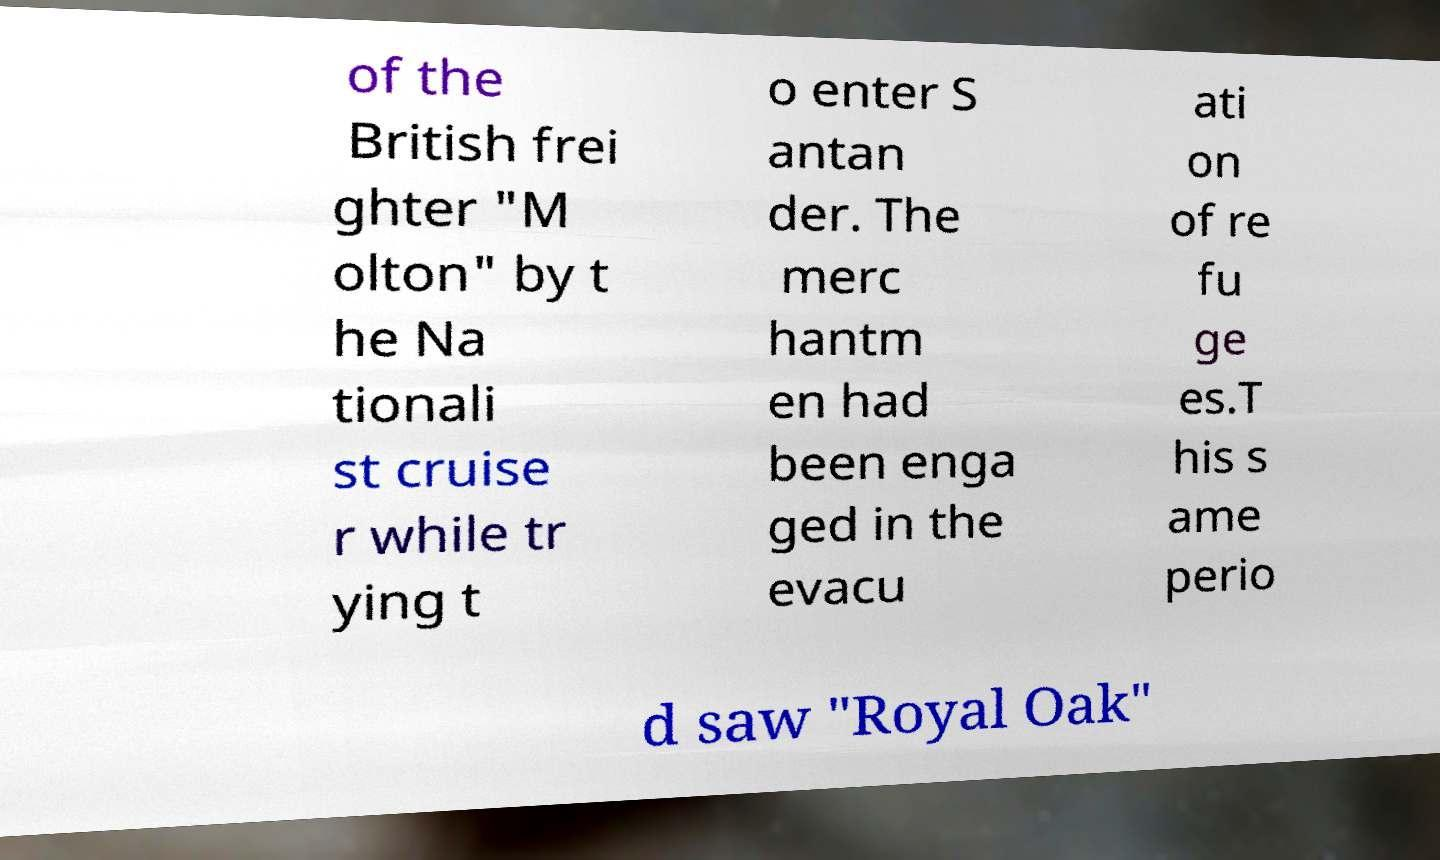Can you accurately transcribe the text from the provided image for me? of the British frei ghter "M olton" by t he Na tionali st cruise r while tr ying t o enter S antan der. The merc hantm en had been enga ged in the evacu ati on of re fu ge es.T his s ame perio d saw "Royal Oak" 